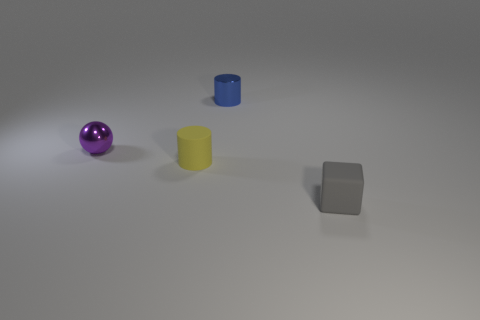Add 3 shiny things. How many objects exist? 7 Subtract all spheres. How many objects are left? 3 Subtract all green cylinders. Subtract all small balls. How many objects are left? 3 Add 2 tiny matte things. How many tiny matte things are left? 4 Add 1 tiny brown matte balls. How many tiny brown matte balls exist? 1 Subtract 1 gray cubes. How many objects are left? 3 Subtract 2 cylinders. How many cylinders are left? 0 Subtract all brown balls. Subtract all gray cubes. How many balls are left? 1 